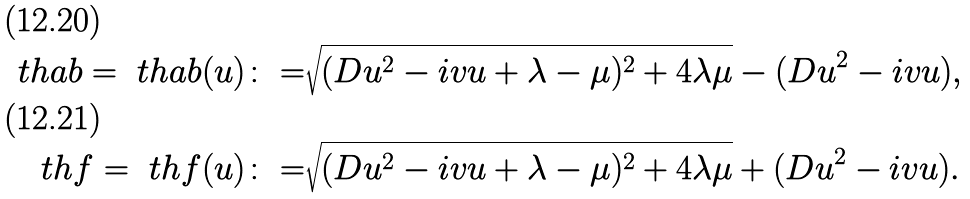Convert formula to latex. <formula><loc_0><loc_0><loc_500><loc_500>\ t h a b = \ t h a b ( u ) \colon = & \sqrt { ( D u ^ { 2 } - i v u + \lambda - \mu ) ^ { 2 } + 4 \lambda \mu } - ( D u ^ { 2 } - i v u ) , \\ \ t h f = \ t h f ( u ) \colon = & \sqrt { ( D u ^ { 2 } - i v u + \lambda - \mu ) ^ { 2 } + 4 \lambda \mu } + ( D u ^ { 2 } - i v u ) .</formula> 